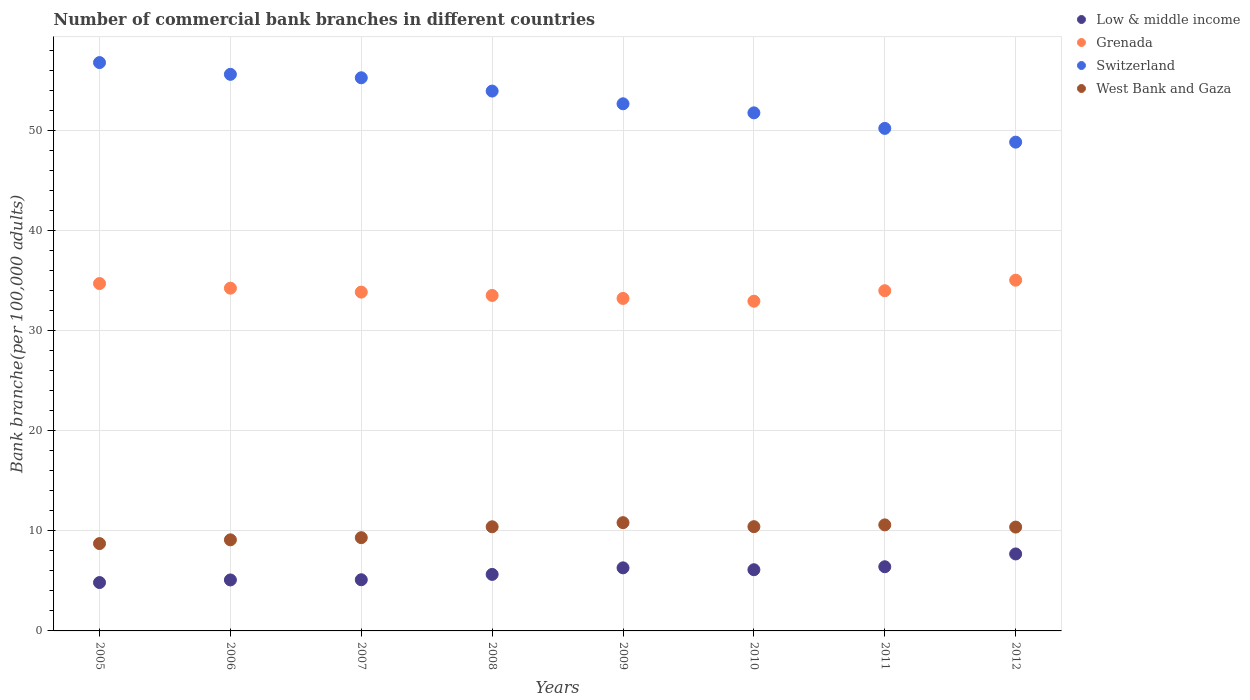Is the number of dotlines equal to the number of legend labels?
Your answer should be compact. Yes. What is the number of commercial bank branches in West Bank and Gaza in 2006?
Keep it short and to the point. 9.1. Across all years, what is the maximum number of commercial bank branches in West Bank and Gaza?
Ensure brevity in your answer.  10.82. Across all years, what is the minimum number of commercial bank branches in Low & middle income?
Ensure brevity in your answer.  4.83. In which year was the number of commercial bank branches in Low & middle income maximum?
Your answer should be very brief. 2012. In which year was the number of commercial bank branches in West Bank and Gaza minimum?
Make the answer very short. 2005. What is the total number of commercial bank branches in Grenada in the graph?
Ensure brevity in your answer.  271.55. What is the difference between the number of commercial bank branches in Grenada in 2007 and that in 2010?
Your response must be concise. 0.91. What is the difference between the number of commercial bank branches in Switzerland in 2008 and the number of commercial bank branches in Grenada in 2010?
Provide a short and direct response. 21. What is the average number of commercial bank branches in Switzerland per year?
Provide a succinct answer. 53.14. In the year 2006, what is the difference between the number of commercial bank branches in Low & middle income and number of commercial bank branches in Grenada?
Give a very brief answer. -29.15. What is the ratio of the number of commercial bank branches in Switzerland in 2007 to that in 2008?
Provide a short and direct response. 1.02. Is the number of commercial bank branches in Grenada in 2008 less than that in 2009?
Provide a succinct answer. No. What is the difference between the highest and the second highest number of commercial bank branches in West Bank and Gaza?
Your response must be concise. 0.22. What is the difference between the highest and the lowest number of commercial bank branches in Low & middle income?
Make the answer very short. 2.86. Is it the case that in every year, the sum of the number of commercial bank branches in West Bank and Gaza and number of commercial bank branches in Grenada  is greater than the sum of number of commercial bank branches in Switzerland and number of commercial bank branches in Low & middle income?
Provide a short and direct response. No. Is it the case that in every year, the sum of the number of commercial bank branches in Low & middle income and number of commercial bank branches in West Bank and Gaza  is greater than the number of commercial bank branches in Switzerland?
Provide a short and direct response. No. Is the number of commercial bank branches in Low & middle income strictly less than the number of commercial bank branches in West Bank and Gaza over the years?
Provide a succinct answer. Yes. What is the difference between two consecutive major ticks on the Y-axis?
Provide a succinct answer. 10. Where does the legend appear in the graph?
Provide a short and direct response. Top right. How many legend labels are there?
Your response must be concise. 4. How are the legend labels stacked?
Your answer should be compact. Vertical. What is the title of the graph?
Your answer should be compact. Number of commercial bank branches in different countries. Does "Middle income" appear as one of the legend labels in the graph?
Offer a very short reply. No. What is the label or title of the Y-axis?
Give a very brief answer. Bank branche(per 100,0 adults). What is the Bank branche(per 100,000 adults) in Low & middle income in 2005?
Provide a succinct answer. 4.83. What is the Bank branche(per 100,000 adults) in Grenada in 2005?
Provide a short and direct response. 34.71. What is the Bank branche(per 100,000 adults) of Switzerland in 2005?
Make the answer very short. 56.79. What is the Bank branche(per 100,000 adults) of West Bank and Gaza in 2005?
Offer a very short reply. 8.73. What is the Bank branche(per 100,000 adults) in Low & middle income in 2006?
Provide a succinct answer. 5.09. What is the Bank branche(per 100,000 adults) of Grenada in 2006?
Make the answer very short. 34.25. What is the Bank branche(per 100,000 adults) of Switzerland in 2006?
Your answer should be compact. 55.62. What is the Bank branche(per 100,000 adults) in West Bank and Gaza in 2006?
Make the answer very short. 9.1. What is the Bank branche(per 100,000 adults) in Low & middle income in 2007?
Offer a terse response. 5.11. What is the Bank branche(per 100,000 adults) of Grenada in 2007?
Your response must be concise. 33.86. What is the Bank branche(per 100,000 adults) of Switzerland in 2007?
Offer a terse response. 55.27. What is the Bank branche(per 100,000 adults) in West Bank and Gaza in 2007?
Your answer should be very brief. 9.32. What is the Bank branche(per 100,000 adults) of Low & middle income in 2008?
Your response must be concise. 5.65. What is the Bank branche(per 100,000 adults) of Grenada in 2008?
Provide a succinct answer. 33.52. What is the Bank branche(per 100,000 adults) of Switzerland in 2008?
Provide a succinct answer. 53.94. What is the Bank branche(per 100,000 adults) in West Bank and Gaza in 2008?
Provide a succinct answer. 10.41. What is the Bank branche(per 100,000 adults) of Low & middle income in 2009?
Keep it short and to the point. 6.3. What is the Bank branche(per 100,000 adults) of Grenada in 2009?
Give a very brief answer. 33.22. What is the Bank branche(per 100,000 adults) of Switzerland in 2009?
Provide a succinct answer. 52.67. What is the Bank branche(per 100,000 adults) of West Bank and Gaza in 2009?
Your answer should be compact. 10.82. What is the Bank branche(per 100,000 adults) of Low & middle income in 2010?
Give a very brief answer. 6.11. What is the Bank branche(per 100,000 adults) in Grenada in 2010?
Your answer should be compact. 32.95. What is the Bank branche(per 100,000 adults) of Switzerland in 2010?
Give a very brief answer. 51.77. What is the Bank branche(per 100,000 adults) in West Bank and Gaza in 2010?
Offer a terse response. 10.42. What is the Bank branche(per 100,000 adults) in Low & middle income in 2011?
Keep it short and to the point. 6.41. What is the Bank branche(per 100,000 adults) of Grenada in 2011?
Make the answer very short. 34. What is the Bank branche(per 100,000 adults) of Switzerland in 2011?
Give a very brief answer. 50.21. What is the Bank branche(per 100,000 adults) in West Bank and Gaza in 2011?
Make the answer very short. 10.6. What is the Bank branche(per 100,000 adults) in Low & middle income in 2012?
Give a very brief answer. 7.69. What is the Bank branche(per 100,000 adults) in Grenada in 2012?
Your response must be concise. 35.05. What is the Bank branche(per 100,000 adults) of Switzerland in 2012?
Give a very brief answer. 48.84. What is the Bank branche(per 100,000 adults) of West Bank and Gaza in 2012?
Your answer should be compact. 10.38. Across all years, what is the maximum Bank branche(per 100,000 adults) of Low & middle income?
Your answer should be very brief. 7.69. Across all years, what is the maximum Bank branche(per 100,000 adults) in Grenada?
Provide a succinct answer. 35.05. Across all years, what is the maximum Bank branche(per 100,000 adults) in Switzerland?
Your answer should be compact. 56.79. Across all years, what is the maximum Bank branche(per 100,000 adults) in West Bank and Gaza?
Keep it short and to the point. 10.82. Across all years, what is the minimum Bank branche(per 100,000 adults) of Low & middle income?
Your response must be concise. 4.83. Across all years, what is the minimum Bank branche(per 100,000 adults) of Grenada?
Provide a short and direct response. 32.95. Across all years, what is the minimum Bank branche(per 100,000 adults) of Switzerland?
Ensure brevity in your answer.  48.84. Across all years, what is the minimum Bank branche(per 100,000 adults) of West Bank and Gaza?
Make the answer very short. 8.73. What is the total Bank branche(per 100,000 adults) in Low & middle income in the graph?
Keep it short and to the point. 47.21. What is the total Bank branche(per 100,000 adults) in Grenada in the graph?
Offer a very short reply. 271.55. What is the total Bank branche(per 100,000 adults) in Switzerland in the graph?
Your answer should be compact. 425.12. What is the total Bank branche(per 100,000 adults) of West Bank and Gaza in the graph?
Your answer should be compact. 79.76. What is the difference between the Bank branche(per 100,000 adults) in Low & middle income in 2005 and that in 2006?
Offer a very short reply. -0.26. What is the difference between the Bank branche(per 100,000 adults) of Grenada in 2005 and that in 2006?
Ensure brevity in your answer.  0.46. What is the difference between the Bank branche(per 100,000 adults) of Switzerland in 2005 and that in 2006?
Make the answer very short. 1.18. What is the difference between the Bank branche(per 100,000 adults) in West Bank and Gaza in 2005 and that in 2006?
Make the answer very short. -0.37. What is the difference between the Bank branche(per 100,000 adults) of Low & middle income in 2005 and that in 2007?
Make the answer very short. -0.28. What is the difference between the Bank branche(per 100,000 adults) in Grenada in 2005 and that in 2007?
Provide a short and direct response. 0.85. What is the difference between the Bank branche(per 100,000 adults) in Switzerland in 2005 and that in 2007?
Keep it short and to the point. 1.52. What is the difference between the Bank branche(per 100,000 adults) of West Bank and Gaza in 2005 and that in 2007?
Ensure brevity in your answer.  -0.59. What is the difference between the Bank branche(per 100,000 adults) in Low & middle income in 2005 and that in 2008?
Offer a terse response. -0.81. What is the difference between the Bank branche(per 100,000 adults) in Grenada in 2005 and that in 2008?
Your answer should be compact. 1.19. What is the difference between the Bank branche(per 100,000 adults) in Switzerland in 2005 and that in 2008?
Ensure brevity in your answer.  2.85. What is the difference between the Bank branche(per 100,000 adults) of West Bank and Gaza in 2005 and that in 2008?
Your answer should be compact. -1.68. What is the difference between the Bank branche(per 100,000 adults) in Low & middle income in 2005 and that in 2009?
Your answer should be compact. -1.47. What is the difference between the Bank branche(per 100,000 adults) of Grenada in 2005 and that in 2009?
Keep it short and to the point. 1.49. What is the difference between the Bank branche(per 100,000 adults) of Switzerland in 2005 and that in 2009?
Your answer should be very brief. 4.12. What is the difference between the Bank branche(per 100,000 adults) of West Bank and Gaza in 2005 and that in 2009?
Provide a succinct answer. -2.09. What is the difference between the Bank branche(per 100,000 adults) in Low & middle income in 2005 and that in 2010?
Offer a very short reply. -1.28. What is the difference between the Bank branche(per 100,000 adults) of Grenada in 2005 and that in 2010?
Keep it short and to the point. 1.76. What is the difference between the Bank branche(per 100,000 adults) of Switzerland in 2005 and that in 2010?
Your answer should be compact. 5.02. What is the difference between the Bank branche(per 100,000 adults) of West Bank and Gaza in 2005 and that in 2010?
Your answer should be very brief. -1.69. What is the difference between the Bank branche(per 100,000 adults) of Low & middle income in 2005 and that in 2011?
Ensure brevity in your answer.  -1.58. What is the difference between the Bank branche(per 100,000 adults) of Grenada in 2005 and that in 2011?
Make the answer very short. 0.71. What is the difference between the Bank branche(per 100,000 adults) of Switzerland in 2005 and that in 2011?
Offer a terse response. 6.58. What is the difference between the Bank branche(per 100,000 adults) of West Bank and Gaza in 2005 and that in 2011?
Your response must be concise. -1.87. What is the difference between the Bank branche(per 100,000 adults) of Low & middle income in 2005 and that in 2012?
Ensure brevity in your answer.  -2.86. What is the difference between the Bank branche(per 100,000 adults) of Grenada in 2005 and that in 2012?
Offer a terse response. -0.34. What is the difference between the Bank branche(per 100,000 adults) in Switzerland in 2005 and that in 2012?
Your answer should be compact. 7.95. What is the difference between the Bank branche(per 100,000 adults) of West Bank and Gaza in 2005 and that in 2012?
Offer a very short reply. -1.65. What is the difference between the Bank branche(per 100,000 adults) of Low & middle income in 2006 and that in 2007?
Provide a short and direct response. -0.02. What is the difference between the Bank branche(per 100,000 adults) in Grenada in 2006 and that in 2007?
Your answer should be very brief. 0.39. What is the difference between the Bank branche(per 100,000 adults) in Switzerland in 2006 and that in 2007?
Give a very brief answer. 0.34. What is the difference between the Bank branche(per 100,000 adults) in West Bank and Gaza in 2006 and that in 2007?
Your answer should be very brief. -0.22. What is the difference between the Bank branche(per 100,000 adults) of Low & middle income in 2006 and that in 2008?
Provide a succinct answer. -0.55. What is the difference between the Bank branche(per 100,000 adults) in Grenada in 2006 and that in 2008?
Give a very brief answer. 0.73. What is the difference between the Bank branche(per 100,000 adults) in Switzerland in 2006 and that in 2008?
Offer a terse response. 1.67. What is the difference between the Bank branche(per 100,000 adults) of West Bank and Gaza in 2006 and that in 2008?
Your response must be concise. -1.3. What is the difference between the Bank branche(per 100,000 adults) in Low & middle income in 2006 and that in 2009?
Your response must be concise. -1.21. What is the difference between the Bank branche(per 100,000 adults) of Grenada in 2006 and that in 2009?
Keep it short and to the point. 1.02. What is the difference between the Bank branche(per 100,000 adults) of Switzerland in 2006 and that in 2009?
Provide a succinct answer. 2.94. What is the difference between the Bank branche(per 100,000 adults) in West Bank and Gaza in 2006 and that in 2009?
Offer a terse response. -1.72. What is the difference between the Bank branche(per 100,000 adults) of Low & middle income in 2006 and that in 2010?
Keep it short and to the point. -1.02. What is the difference between the Bank branche(per 100,000 adults) in Grenada in 2006 and that in 2010?
Make the answer very short. 1.3. What is the difference between the Bank branche(per 100,000 adults) of Switzerland in 2006 and that in 2010?
Offer a terse response. 3.85. What is the difference between the Bank branche(per 100,000 adults) in West Bank and Gaza in 2006 and that in 2010?
Offer a very short reply. -1.32. What is the difference between the Bank branche(per 100,000 adults) of Low & middle income in 2006 and that in 2011?
Offer a very short reply. -1.32. What is the difference between the Bank branche(per 100,000 adults) of Grenada in 2006 and that in 2011?
Provide a short and direct response. 0.25. What is the difference between the Bank branche(per 100,000 adults) of Switzerland in 2006 and that in 2011?
Your answer should be very brief. 5.4. What is the difference between the Bank branche(per 100,000 adults) of West Bank and Gaza in 2006 and that in 2011?
Give a very brief answer. -1.49. What is the difference between the Bank branche(per 100,000 adults) in Low & middle income in 2006 and that in 2012?
Offer a very short reply. -2.6. What is the difference between the Bank branche(per 100,000 adults) in Grenada in 2006 and that in 2012?
Offer a terse response. -0.8. What is the difference between the Bank branche(per 100,000 adults) of Switzerland in 2006 and that in 2012?
Your answer should be very brief. 6.78. What is the difference between the Bank branche(per 100,000 adults) in West Bank and Gaza in 2006 and that in 2012?
Offer a very short reply. -1.27. What is the difference between the Bank branche(per 100,000 adults) in Low & middle income in 2007 and that in 2008?
Ensure brevity in your answer.  -0.53. What is the difference between the Bank branche(per 100,000 adults) of Grenada in 2007 and that in 2008?
Keep it short and to the point. 0.33. What is the difference between the Bank branche(per 100,000 adults) in Switzerland in 2007 and that in 2008?
Your answer should be very brief. 1.33. What is the difference between the Bank branche(per 100,000 adults) in West Bank and Gaza in 2007 and that in 2008?
Ensure brevity in your answer.  -1.09. What is the difference between the Bank branche(per 100,000 adults) of Low & middle income in 2007 and that in 2009?
Your response must be concise. -1.19. What is the difference between the Bank branche(per 100,000 adults) of Grenada in 2007 and that in 2009?
Keep it short and to the point. 0.63. What is the difference between the Bank branche(per 100,000 adults) of Switzerland in 2007 and that in 2009?
Your response must be concise. 2.6. What is the difference between the Bank branche(per 100,000 adults) of West Bank and Gaza in 2007 and that in 2009?
Ensure brevity in your answer.  -1.5. What is the difference between the Bank branche(per 100,000 adults) in Low & middle income in 2007 and that in 2010?
Offer a very short reply. -1. What is the difference between the Bank branche(per 100,000 adults) in Grenada in 2007 and that in 2010?
Offer a very short reply. 0.91. What is the difference between the Bank branche(per 100,000 adults) of Switzerland in 2007 and that in 2010?
Your answer should be very brief. 3.5. What is the difference between the Bank branche(per 100,000 adults) of West Bank and Gaza in 2007 and that in 2010?
Offer a terse response. -1.1. What is the difference between the Bank branche(per 100,000 adults) of Low & middle income in 2007 and that in 2011?
Your response must be concise. -1.3. What is the difference between the Bank branche(per 100,000 adults) of Grenada in 2007 and that in 2011?
Your answer should be compact. -0.14. What is the difference between the Bank branche(per 100,000 adults) in Switzerland in 2007 and that in 2011?
Your answer should be compact. 5.06. What is the difference between the Bank branche(per 100,000 adults) in West Bank and Gaza in 2007 and that in 2011?
Offer a terse response. -1.28. What is the difference between the Bank branche(per 100,000 adults) of Low & middle income in 2007 and that in 2012?
Provide a succinct answer. -2.58. What is the difference between the Bank branche(per 100,000 adults) in Grenada in 2007 and that in 2012?
Your answer should be very brief. -1.19. What is the difference between the Bank branche(per 100,000 adults) in Switzerland in 2007 and that in 2012?
Your answer should be compact. 6.43. What is the difference between the Bank branche(per 100,000 adults) of West Bank and Gaza in 2007 and that in 2012?
Keep it short and to the point. -1.06. What is the difference between the Bank branche(per 100,000 adults) of Low & middle income in 2008 and that in 2009?
Offer a very short reply. -0.66. What is the difference between the Bank branche(per 100,000 adults) of Grenada in 2008 and that in 2009?
Offer a terse response. 0.3. What is the difference between the Bank branche(per 100,000 adults) of Switzerland in 2008 and that in 2009?
Provide a succinct answer. 1.27. What is the difference between the Bank branche(per 100,000 adults) of West Bank and Gaza in 2008 and that in 2009?
Provide a succinct answer. -0.41. What is the difference between the Bank branche(per 100,000 adults) in Low & middle income in 2008 and that in 2010?
Your answer should be very brief. -0.47. What is the difference between the Bank branche(per 100,000 adults) of Grenada in 2008 and that in 2010?
Provide a succinct answer. 0.58. What is the difference between the Bank branche(per 100,000 adults) in Switzerland in 2008 and that in 2010?
Provide a short and direct response. 2.18. What is the difference between the Bank branche(per 100,000 adults) in West Bank and Gaza in 2008 and that in 2010?
Your answer should be compact. -0.01. What is the difference between the Bank branche(per 100,000 adults) in Low & middle income in 2008 and that in 2011?
Your answer should be compact. -0.76. What is the difference between the Bank branche(per 100,000 adults) in Grenada in 2008 and that in 2011?
Provide a short and direct response. -0.47. What is the difference between the Bank branche(per 100,000 adults) in Switzerland in 2008 and that in 2011?
Ensure brevity in your answer.  3.73. What is the difference between the Bank branche(per 100,000 adults) of West Bank and Gaza in 2008 and that in 2011?
Make the answer very short. -0.19. What is the difference between the Bank branche(per 100,000 adults) in Low & middle income in 2008 and that in 2012?
Make the answer very short. -2.04. What is the difference between the Bank branche(per 100,000 adults) of Grenada in 2008 and that in 2012?
Offer a terse response. -1.52. What is the difference between the Bank branche(per 100,000 adults) in Switzerland in 2008 and that in 2012?
Give a very brief answer. 5.1. What is the difference between the Bank branche(per 100,000 adults) in West Bank and Gaza in 2008 and that in 2012?
Your answer should be very brief. 0.03. What is the difference between the Bank branche(per 100,000 adults) of Low & middle income in 2009 and that in 2010?
Make the answer very short. 0.19. What is the difference between the Bank branche(per 100,000 adults) of Grenada in 2009 and that in 2010?
Offer a very short reply. 0.28. What is the difference between the Bank branche(per 100,000 adults) of Switzerland in 2009 and that in 2010?
Your answer should be compact. 0.9. What is the difference between the Bank branche(per 100,000 adults) of West Bank and Gaza in 2009 and that in 2010?
Your answer should be very brief. 0.4. What is the difference between the Bank branche(per 100,000 adults) of Low & middle income in 2009 and that in 2011?
Ensure brevity in your answer.  -0.11. What is the difference between the Bank branche(per 100,000 adults) in Grenada in 2009 and that in 2011?
Your answer should be compact. -0.77. What is the difference between the Bank branche(per 100,000 adults) in Switzerland in 2009 and that in 2011?
Keep it short and to the point. 2.46. What is the difference between the Bank branche(per 100,000 adults) of West Bank and Gaza in 2009 and that in 2011?
Your answer should be very brief. 0.22. What is the difference between the Bank branche(per 100,000 adults) of Low & middle income in 2009 and that in 2012?
Give a very brief answer. -1.39. What is the difference between the Bank branche(per 100,000 adults) in Grenada in 2009 and that in 2012?
Your answer should be compact. -1.82. What is the difference between the Bank branche(per 100,000 adults) in Switzerland in 2009 and that in 2012?
Offer a terse response. 3.83. What is the difference between the Bank branche(per 100,000 adults) in West Bank and Gaza in 2009 and that in 2012?
Offer a very short reply. 0.44. What is the difference between the Bank branche(per 100,000 adults) of Low & middle income in 2010 and that in 2011?
Keep it short and to the point. -0.3. What is the difference between the Bank branche(per 100,000 adults) of Grenada in 2010 and that in 2011?
Ensure brevity in your answer.  -1.05. What is the difference between the Bank branche(per 100,000 adults) of Switzerland in 2010 and that in 2011?
Offer a very short reply. 1.55. What is the difference between the Bank branche(per 100,000 adults) of West Bank and Gaza in 2010 and that in 2011?
Offer a very short reply. -0.18. What is the difference between the Bank branche(per 100,000 adults) in Low & middle income in 2010 and that in 2012?
Provide a succinct answer. -1.58. What is the difference between the Bank branche(per 100,000 adults) of Grenada in 2010 and that in 2012?
Offer a very short reply. -2.1. What is the difference between the Bank branche(per 100,000 adults) of Switzerland in 2010 and that in 2012?
Offer a terse response. 2.93. What is the difference between the Bank branche(per 100,000 adults) in West Bank and Gaza in 2010 and that in 2012?
Offer a very short reply. 0.04. What is the difference between the Bank branche(per 100,000 adults) in Low & middle income in 2011 and that in 2012?
Provide a short and direct response. -1.28. What is the difference between the Bank branche(per 100,000 adults) in Grenada in 2011 and that in 2012?
Your response must be concise. -1.05. What is the difference between the Bank branche(per 100,000 adults) of Switzerland in 2011 and that in 2012?
Your answer should be compact. 1.37. What is the difference between the Bank branche(per 100,000 adults) of West Bank and Gaza in 2011 and that in 2012?
Provide a succinct answer. 0.22. What is the difference between the Bank branche(per 100,000 adults) of Low & middle income in 2005 and the Bank branche(per 100,000 adults) of Grenada in 2006?
Offer a very short reply. -29.41. What is the difference between the Bank branche(per 100,000 adults) of Low & middle income in 2005 and the Bank branche(per 100,000 adults) of Switzerland in 2006?
Your response must be concise. -50.78. What is the difference between the Bank branche(per 100,000 adults) in Low & middle income in 2005 and the Bank branche(per 100,000 adults) in West Bank and Gaza in 2006?
Offer a very short reply. -4.27. What is the difference between the Bank branche(per 100,000 adults) of Grenada in 2005 and the Bank branche(per 100,000 adults) of Switzerland in 2006?
Your answer should be very brief. -20.91. What is the difference between the Bank branche(per 100,000 adults) in Grenada in 2005 and the Bank branche(per 100,000 adults) in West Bank and Gaza in 2006?
Your answer should be very brief. 25.61. What is the difference between the Bank branche(per 100,000 adults) of Switzerland in 2005 and the Bank branche(per 100,000 adults) of West Bank and Gaza in 2006?
Provide a short and direct response. 47.69. What is the difference between the Bank branche(per 100,000 adults) of Low & middle income in 2005 and the Bank branche(per 100,000 adults) of Grenada in 2007?
Provide a succinct answer. -29.02. What is the difference between the Bank branche(per 100,000 adults) of Low & middle income in 2005 and the Bank branche(per 100,000 adults) of Switzerland in 2007?
Ensure brevity in your answer.  -50.44. What is the difference between the Bank branche(per 100,000 adults) of Low & middle income in 2005 and the Bank branche(per 100,000 adults) of West Bank and Gaza in 2007?
Provide a short and direct response. -4.49. What is the difference between the Bank branche(per 100,000 adults) in Grenada in 2005 and the Bank branche(per 100,000 adults) in Switzerland in 2007?
Keep it short and to the point. -20.56. What is the difference between the Bank branche(per 100,000 adults) in Grenada in 2005 and the Bank branche(per 100,000 adults) in West Bank and Gaza in 2007?
Offer a very short reply. 25.39. What is the difference between the Bank branche(per 100,000 adults) of Switzerland in 2005 and the Bank branche(per 100,000 adults) of West Bank and Gaza in 2007?
Provide a short and direct response. 47.47. What is the difference between the Bank branche(per 100,000 adults) in Low & middle income in 2005 and the Bank branche(per 100,000 adults) in Grenada in 2008?
Offer a very short reply. -28.69. What is the difference between the Bank branche(per 100,000 adults) in Low & middle income in 2005 and the Bank branche(per 100,000 adults) in Switzerland in 2008?
Offer a terse response. -49.11. What is the difference between the Bank branche(per 100,000 adults) of Low & middle income in 2005 and the Bank branche(per 100,000 adults) of West Bank and Gaza in 2008?
Your response must be concise. -5.57. What is the difference between the Bank branche(per 100,000 adults) of Grenada in 2005 and the Bank branche(per 100,000 adults) of Switzerland in 2008?
Your answer should be very brief. -19.23. What is the difference between the Bank branche(per 100,000 adults) in Grenada in 2005 and the Bank branche(per 100,000 adults) in West Bank and Gaza in 2008?
Ensure brevity in your answer.  24.3. What is the difference between the Bank branche(per 100,000 adults) in Switzerland in 2005 and the Bank branche(per 100,000 adults) in West Bank and Gaza in 2008?
Keep it short and to the point. 46.39. What is the difference between the Bank branche(per 100,000 adults) in Low & middle income in 2005 and the Bank branche(per 100,000 adults) in Grenada in 2009?
Your response must be concise. -28.39. What is the difference between the Bank branche(per 100,000 adults) in Low & middle income in 2005 and the Bank branche(per 100,000 adults) in Switzerland in 2009?
Keep it short and to the point. -47.84. What is the difference between the Bank branche(per 100,000 adults) of Low & middle income in 2005 and the Bank branche(per 100,000 adults) of West Bank and Gaza in 2009?
Provide a short and direct response. -5.98. What is the difference between the Bank branche(per 100,000 adults) of Grenada in 2005 and the Bank branche(per 100,000 adults) of Switzerland in 2009?
Your answer should be very brief. -17.96. What is the difference between the Bank branche(per 100,000 adults) in Grenada in 2005 and the Bank branche(per 100,000 adults) in West Bank and Gaza in 2009?
Your answer should be very brief. 23.89. What is the difference between the Bank branche(per 100,000 adults) of Switzerland in 2005 and the Bank branche(per 100,000 adults) of West Bank and Gaza in 2009?
Offer a terse response. 45.97. What is the difference between the Bank branche(per 100,000 adults) in Low & middle income in 2005 and the Bank branche(per 100,000 adults) in Grenada in 2010?
Give a very brief answer. -28.11. What is the difference between the Bank branche(per 100,000 adults) of Low & middle income in 2005 and the Bank branche(per 100,000 adults) of Switzerland in 2010?
Give a very brief answer. -46.93. What is the difference between the Bank branche(per 100,000 adults) in Low & middle income in 2005 and the Bank branche(per 100,000 adults) in West Bank and Gaza in 2010?
Make the answer very short. -5.58. What is the difference between the Bank branche(per 100,000 adults) in Grenada in 2005 and the Bank branche(per 100,000 adults) in Switzerland in 2010?
Make the answer very short. -17.06. What is the difference between the Bank branche(per 100,000 adults) of Grenada in 2005 and the Bank branche(per 100,000 adults) of West Bank and Gaza in 2010?
Your response must be concise. 24.29. What is the difference between the Bank branche(per 100,000 adults) in Switzerland in 2005 and the Bank branche(per 100,000 adults) in West Bank and Gaza in 2010?
Make the answer very short. 46.37. What is the difference between the Bank branche(per 100,000 adults) in Low & middle income in 2005 and the Bank branche(per 100,000 adults) in Grenada in 2011?
Offer a terse response. -29.16. What is the difference between the Bank branche(per 100,000 adults) in Low & middle income in 2005 and the Bank branche(per 100,000 adults) in Switzerland in 2011?
Keep it short and to the point. -45.38. What is the difference between the Bank branche(per 100,000 adults) of Low & middle income in 2005 and the Bank branche(per 100,000 adults) of West Bank and Gaza in 2011?
Ensure brevity in your answer.  -5.76. What is the difference between the Bank branche(per 100,000 adults) of Grenada in 2005 and the Bank branche(per 100,000 adults) of Switzerland in 2011?
Make the answer very short. -15.5. What is the difference between the Bank branche(per 100,000 adults) of Grenada in 2005 and the Bank branche(per 100,000 adults) of West Bank and Gaza in 2011?
Make the answer very short. 24.11. What is the difference between the Bank branche(per 100,000 adults) in Switzerland in 2005 and the Bank branche(per 100,000 adults) in West Bank and Gaza in 2011?
Offer a very short reply. 46.2. What is the difference between the Bank branche(per 100,000 adults) in Low & middle income in 2005 and the Bank branche(per 100,000 adults) in Grenada in 2012?
Give a very brief answer. -30.21. What is the difference between the Bank branche(per 100,000 adults) in Low & middle income in 2005 and the Bank branche(per 100,000 adults) in Switzerland in 2012?
Offer a terse response. -44.01. What is the difference between the Bank branche(per 100,000 adults) of Low & middle income in 2005 and the Bank branche(per 100,000 adults) of West Bank and Gaza in 2012?
Offer a terse response. -5.54. What is the difference between the Bank branche(per 100,000 adults) in Grenada in 2005 and the Bank branche(per 100,000 adults) in Switzerland in 2012?
Keep it short and to the point. -14.13. What is the difference between the Bank branche(per 100,000 adults) in Grenada in 2005 and the Bank branche(per 100,000 adults) in West Bank and Gaza in 2012?
Offer a terse response. 24.33. What is the difference between the Bank branche(per 100,000 adults) of Switzerland in 2005 and the Bank branche(per 100,000 adults) of West Bank and Gaza in 2012?
Provide a succinct answer. 46.42. What is the difference between the Bank branche(per 100,000 adults) in Low & middle income in 2006 and the Bank branche(per 100,000 adults) in Grenada in 2007?
Your answer should be very brief. -28.76. What is the difference between the Bank branche(per 100,000 adults) of Low & middle income in 2006 and the Bank branche(per 100,000 adults) of Switzerland in 2007?
Ensure brevity in your answer.  -50.18. What is the difference between the Bank branche(per 100,000 adults) in Low & middle income in 2006 and the Bank branche(per 100,000 adults) in West Bank and Gaza in 2007?
Your answer should be compact. -4.22. What is the difference between the Bank branche(per 100,000 adults) in Grenada in 2006 and the Bank branche(per 100,000 adults) in Switzerland in 2007?
Offer a very short reply. -21.02. What is the difference between the Bank branche(per 100,000 adults) of Grenada in 2006 and the Bank branche(per 100,000 adults) of West Bank and Gaza in 2007?
Offer a terse response. 24.93. What is the difference between the Bank branche(per 100,000 adults) of Switzerland in 2006 and the Bank branche(per 100,000 adults) of West Bank and Gaza in 2007?
Your answer should be compact. 46.3. What is the difference between the Bank branche(per 100,000 adults) in Low & middle income in 2006 and the Bank branche(per 100,000 adults) in Grenada in 2008?
Provide a succinct answer. -28.43. What is the difference between the Bank branche(per 100,000 adults) in Low & middle income in 2006 and the Bank branche(per 100,000 adults) in Switzerland in 2008?
Offer a very short reply. -48.85. What is the difference between the Bank branche(per 100,000 adults) of Low & middle income in 2006 and the Bank branche(per 100,000 adults) of West Bank and Gaza in 2008?
Offer a very short reply. -5.31. What is the difference between the Bank branche(per 100,000 adults) in Grenada in 2006 and the Bank branche(per 100,000 adults) in Switzerland in 2008?
Your answer should be very brief. -19.7. What is the difference between the Bank branche(per 100,000 adults) in Grenada in 2006 and the Bank branche(per 100,000 adults) in West Bank and Gaza in 2008?
Your response must be concise. 23.84. What is the difference between the Bank branche(per 100,000 adults) in Switzerland in 2006 and the Bank branche(per 100,000 adults) in West Bank and Gaza in 2008?
Your answer should be compact. 45.21. What is the difference between the Bank branche(per 100,000 adults) in Low & middle income in 2006 and the Bank branche(per 100,000 adults) in Grenada in 2009?
Provide a succinct answer. -28.13. What is the difference between the Bank branche(per 100,000 adults) of Low & middle income in 2006 and the Bank branche(per 100,000 adults) of Switzerland in 2009?
Offer a very short reply. -47.58. What is the difference between the Bank branche(per 100,000 adults) in Low & middle income in 2006 and the Bank branche(per 100,000 adults) in West Bank and Gaza in 2009?
Offer a terse response. -5.72. What is the difference between the Bank branche(per 100,000 adults) in Grenada in 2006 and the Bank branche(per 100,000 adults) in Switzerland in 2009?
Offer a terse response. -18.42. What is the difference between the Bank branche(per 100,000 adults) in Grenada in 2006 and the Bank branche(per 100,000 adults) in West Bank and Gaza in 2009?
Your answer should be compact. 23.43. What is the difference between the Bank branche(per 100,000 adults) in Switzerland in 2006 and the Bank branche(per 100,000 adults) in West Bank and Gaza in 2009?
Ensure brevity in your answer.  44.8. What is the difference between the Bank branche(per 100,000 adults) of Low & middle income in 2006 and the Bank branche(per 100,000 adults) of Grenada in 2010?
Offer a very short reply. -27.85. What is the difference between the Bank branche(per 100,000 adults) in Low & middle income in 2006 and the Bank branche(per 100,000 adults) in Switzerland in 2010?
Offer a very short reply. -46.67. What is the difference between the Bank branche(per 100,000 adults) of Low & middle income in 2006 and the Bank branche(per 100,000 adults) of West Bank and Gaza in 2010?
Your answer should be very brief. -5.32. What is the difference between the Bank branche(per 100,000 adults) in Grenada in 2006 and the Bank branche(per 100,000 adults) in Switzerland in 2010?
Provide a succinct answer. -17.52. What is the difference between the Bank branche(per 100,000 adults) of Grenada in 2006 and the Bank branche(per 100,000 adults) of West Bank and Gaza in 2010?
Offer a terse response. 23.83. What is the difference between the Bank branche(per 100,000 adults) of Switzerland in 2006 and the Bank branche(per 100,000 adults) of West Bank and Gaza in 2010?
Provide a short and direct response. 45.2. What is the difference between the Bank branche(per 100,000 adults) in Low & middle income in 2006 and the Bank branche(per 100,000 adults) in Grenada in 2011?
Your answer should be very brief. -28.9. What is the difference between the Bank branche(per 100,000 adults) in Low & middle income in 2006 and the Bank branche(per 100,000 adults) in Switzerland in 2011?
Offer a very short reply. -45.12. What is the difference between the Bank branche(per 100,000 adults) in Low & middle income in 2006 and the Bank branche(per 100,000 adults) in West Bank and Gaza in 2011?
Your answer should be very brief. -5.5. What is the difference between the Bank branche(per 100,000 adults) in Grenada in 2006 and the Bank branche(per 100,000 adults) in Switzerland in 2011?
Offer a very short reply. -15.97. What is the difference between the Bank branche(per 100,000 adults) in Grenada in 2006 and the Bank branche(per 100,000 adults) in West Bank and Gaza in 2011?
Your answer should be compact. 23.65. What is the difference between the Bank branche(per 100,000 adults) of Switzerland in 2006 and the Bank branche(per 100,000 adults) of West Bank and Gaza in 2011?
Ensure brevity in your answer.  45.02. What is the difference between the Bank branche(per 100,000 adults) of Low & middle income in 2006 and the Bank branche(per 100,000 adults) of Grenada in 2012?
Offer a terse response. -29.95. What is the difference between the Bank branche(per 100,000 adults) of Low & middle income in 2006 and the Bank branche(per 100,000 adults) of Switzerland in 2012?
Ensure brevity in your answer.  -43.75. What is the difference between the Bank branche(per 100,000 adults) of Low & middle income in 2006 and the Bank branche(per 100,000 adults) of West Bank and Gaza in 2012?
Provide a short and direct response. -5.28. What is the difference between the Bank branche(per 100,000 adults) of Grenada in 2006 and the Bank branche(per 100,000 adults) of Switzerland in 2012?
Ensure brevity in your answer.  -14.59. What is the difference between the Bank branche(per 100,000 adults) in Grenada in 2006 and the Bank branche(per 100,000 adults) in West Bank and Gaza in 2012?
Keep it short and to the point. 23.87. What is the difference between the Bank branche(per 100,000 adults) of Switzerland in 2006 and the Bank branche(per 100,000 adults) of West Bank and Gaza in 2012?
Ensure brevity in your answer.  45.24. What is the difference between the Bank branche(per 100,000 adults) in Low & middle income in 2007 and the Bank branche(per 100,000 adults) in Grenada in 2008?
Offer a terse response. -28.41. What is the difference between the Bank branche(per 100,000 adults) of Low & middle income in 2007 and the Bank branche(per 100,000 adults) of Switzerland in 2008?
Your response must be concise. -48.83. What is the difference between the Bank branche(per 100,000 adults) in Low & middle income in 2007 and the Bank branche(per 100,000 adults) in West Bank and Gaza in 2008?
Ensure brevity in your answer.  -5.29. What is the difference between the Bank branche(per 100,000 adults) in Grenada in 2007 and the Bank branche(per 100,000 adults) in Switzerland in 2008?
Provide a short and direct response. -20.09. What is the difference between the Bank branche(per 100,000 adults) of Grenada in 2007 and the Bank branche(per 100,000 adults) of West Bank and Gaza in 2008?
Ensure brevity in your answer.  23.45. What is the difference between the Bank branche(per 100,000 adults) of Switzerland in 2007 and the Bank branche(per 100,000 adults) of West Bank and Gaza in 2008?
Provide a succinct answer. 44.87. What is the difference between the Bank branche(per 100,000 adults) of Low & middle income in 2007 and the Bank branche(per 100,000 adults) of Grenada in 2009?
Give a very brief answer. -28.11. What is the difference between the Bank branche(per 100,000 adults) of Low & middle income in 2007 and the Bank branche(per 100,000 adults) of Switzerland in 2009?
Give a very brief answer. -47.56. What is the difference between the Bank branche(per 100,000 adults) in Low & middle income in 2007 and the Bank branche(per 100,000 adults) in West Bank and Gaza in 2009?
Provide a succinct answer. -5.71. What is the difference between the Bank branche(per 100,000 adults) in Grenada in 2007 and the Bank branche(per 100,000 adults) in Switzerland in 2009?
Provide a short and direct response. -18.82. What is the difference between the Bank branche(per 100,000 adults) in Grenada in 2007 and the Bank branche(per 100,000 adults) in West Bank and Gaza in 2009?
Make the answer very short. 23.04. What is the difference between the Bank branche(per 100,000 adults) in Switzerland in 2007 and the Bank branche(per 100,000 adults) in West Bank and Gaza in 2009?
Give a very brief answer. 44.45. What is the difference between the Bank branche(per 100,000 adults) in Low & middle income in 2007 and the Bank branche(per 100,000 adults) in Grenada in 2010?
Offer a terse response. -27.83. What is the difference between the Bank branche(per 100,000 adults) of Low & middle income in 2007 and the Bank branche(per 100,000 adults) of Switzerland in 2010?
Make the answer very short. -46.66. What is the difference between the Bank branche(per 100,000 adults) in Low & middle income in 2007 and the Bank branche(per 100,000 adults) in West Bank and Gaza in 2010?
Your answer should be very brief. -5.31. What is the difference between the Bank branche(per 100,000 adults) of Grenada in 2007 and the Bank branche(per 100,000 adults) of Switzerland in 2010?
Keep it short and to the point. -17.91. What is the difference between the Bank branche(per 100,000 adults) in Grenada in 2007 and the Bank branche(per 100,000 adults) in West Bank and Gaza in 2010?
Ensure brevity in your answer.  23.44. What is the difference between the Bank branche(per 100,000 adults) of Switzerland in 2007 and the Bank branche(per 100,000 adults) of West Bank and Gaza in 2010?
Your response must be concise. 44.86. What is the difference between the Bank branche(per 100,000 adults) in Low & middle income in 2007 and the Bank branche(per 100,000 adults) in Grenada in 2011?
Ensure brevity in your answer.  -28.88. What is the difference between the Bank branche(per 100,000 adults) of Low & middle income in 2007 and the Bank branche(per 100,000 adults) of Switzerland in 2011?
Ensure brevity in your answer.  -45.1. What is the difference between the Bank branche(per 100,000 adults) of Low & middle income in 2007 and the Bank branche(per 100,000 adults) of West Bank and Gaza in 2011?
Provide a short and direct response. -5.48. What is the difference between the Bank branche(per 100,000 adults) in Grenada in 2007 and the Bank branche(per 100,000 adults) in Switzerland in 2011?
Offer a terse response. -16.36. What is the difference between the Bank branche(per 100,000 adults) in Grenada in 2007 and the Bank branche(per 100,000 adults) in West Bank and Gaza in 2011?
Provide a short and direct response. 23.26. What is the difference between the Bank branche(per 100,000 adults) of Switzerland in 2007 and the Bank branche(per 100,000 adults) of West Bank and Gaza in 2011?
Offer a terse response. 44.68. What is the difference between the Bank branche(per 100,000 adults) in Low & middle income in 2007 and the Bank branche(per 100,000 adults) in Grenada in 2012?
Give a very brief answer. -29.93. What is the difference between the Bank branche(per 100,000 adults) in Low & middle income in 2007 and the Bank branche(per 100,000 adults) in Switzerland in 2012?
Offer a very short reply. -43.73. What is the difference between the Bank branche(per 100,000 adults) of Low & middle income in 2007 and the Bank branche(per 100,000 adults) of West Bank and Gaza in 2012?
Your response must be concise. -5.26. What is the difference between the Bank branche(per 100,000 adults) in Grenada in 2007 and the Bank branche(per 100,000 adults) in Switzerland in 2012?
Make the answer very short. -14.99. What is the difference between the Bank branche(per 100,000 adults) of Grenada in 2007 and the Bank branche(per 100,000 adults) of West Bank and Gaza in 2012?
Keep it short and to the point. 23.48. What is the difference between the Bank branche(per 100,000 adults) in Switzerland in 2007 and the Bank branche(per 100,000 adults) in West Bank and Gaza in 2012?
Ensure brevity in your answer.  44.9. What is the difference between the Bank branche(per 100,000 adults) in Low & middle income in 2008 and the Bank branche(per 100,000 adults) in Grenada in 2009?
Keep it short and to the point. -27.58. What is the difference between the Bank branche(per 100,000 adults) of Low & middle income in 2008 and the Bank branche(per 100,000 adults) of Switzerland in 2009?
Give a very brief answer. -47.03. What is the difference between the Bank branche(per 100,000 adults) in Low & middle income in 2008 and the Bank branche(per 100,000 adults) in West Bank and Gaza in 2009?
Keep it short and to the point. -5.17. What is the difference between the Bank branche(per 100,000 adults) of Grenada in 2008 and the Bank branche(per 100,000 adults) of Switzerland in 2009?
Offer a very short reply. -19.15. What is the difference between the Bank branche(per 100,000 adults) in Grenada in 2008 and the Bank branche(per 100,000 adults) in West Bank and Gaza in 2009?
Your answer should be very brief. 22.7. What is the difference between the Bank branche(per 100,000 adults) in Switzerland in 2008 and the Bank branche(per 100,000 adults) in West Bank and Gaza in 2009?
Make the answer very short. 43.13. What is the difference between the Bank branche(per 100,000 adults) in Low & middle income in 2008 and the Bank branche(per 100,000 adults) in Grenada in 2010?
Make the answer very short. -27.3. What is the difference between the Bank branche(per 100,000 adults) of Low & middle income in 2008 and the Bank branche(per 100,000 adults) of Switzerland in 2010?
Offer a terse response. -46.12. What is the difference between the Bank branche(per 100,000 adults) in Low & middle income in 2008 and the Bank branche(per 100,000 adults) in West Bank and Gaza in 2010?
Your response must be concise. -4.77. What is the difference between the Bank branche(per 100,000 adults) in Grenada in 2008 and the Bank branche(per 100,000 adults) in Switzerland in 2010?
Provide a succinct answer. -18.25. What is the difference between the Bank branche(per 100,000 adults) in Grenada in 2008 and the Bank branche(per 100,000 adults) in West Bank and Gaza in 2010?
Your response must be concise. 23.1. What is the difference between the Bank branche(per 100,000 adults) in Switzerland in 2008 and the Bank branche(per 100,000 adults) in West Bank and Gaza in 2010?
Ensure brevity in your answer.  43.53. What is the difference between the Bank branche(per 100,000 adults) of Low & middle income in 2008 and the Bank branche(per 100,000 adults) of Grenada in 2011?
Provide a succinct answer. -28.35. What is the difference between the Bank branche(per 100,000 adults) in Low & middle income in 2008 and the Bank branche(per 100,000 adults) in Switzerland in 2011?
Offer a terse response. -44.57. What is the difference between the Bank branche(per 100,000 adults) of Low & middle income in 2008 and the Bank branche(per 100,000 adults) of West Bank and Gaza in 2011?
Offer a terse response. -4.95. What is the difference between the Bank branche(per 100,000 adults) in Grenada in 2008 and the Bank branche(per 100,000 adults) in Switzerland in 2011?
Ensure brevity in your answer.  -16.69. What is the difference between the Bank branche(per 100,000 adults) of Grenada in 2008 and the Bank branche(per 100,000 adults) of West Bank and Gaza in 2011?
Give a very brief answer. 22.93. What is the difference between the Bank branche(per 100,000 adults) in Switzerland in 2008 and the Bank branche(per 100,000 adults) in West Bank and Gaza in 2011?
Give a very brief answer. 43.35. What is the difference between the Bank branche(per 100,000 adults) in Low & middle income in 2008 and the Bank branche(per 100,000 adults) in Grenada in 2012?
Provide a succinct answer. -29.4. What is the difference between the Bank branche(per 100,000 adults) of Low & middle income in 2008 and the Bank branche(per 100,000 adults) of Switzerland in 2012?
Ensure brevity in your answer.  -43.19. What is the difference between the Bank branche(per 100,000 adults) in Low & middle income in 2008 and the Bank branche(per 100,000 adults) in West Bank and Gaza in 2012?
Give a very brief answer. -4.73. What is the difference between the Bank branche(per 100,000 adults) of Grenada in 2008 and the Bank branche(per 100,000 adults) of Switzerland in 2012?
Your response must be concise. -15.32. What is the difference between the Bank branche(per 100,000 adults) of Grenada in 2008 and the Bank branche(per 100,000 adults) of West Bank and Gaza in 2012?
Give a very brief answer. 23.15. What is the difference between the Bank branche(per 100,000 adults) in Switzerland in 2008 and the Bank branche(per 100,000 adults) in West Bank and Gaza in 2012?
Keep it short and to the point. 43.57. What is the difference between the Bank branche(per 100,000 adults) of Low & middle income in 2009 and the Bank branche(per 100,000 adults) of Grenada in 2010?
Your answer should be very brief. -26.64. What is the difference between the Bank branche(per 100,000 adults) of Low & middle income in 2009 and the Bank branche(per 100,000 adults) of Switzerland in 2010?
Your response must be concise. -45.47. What is the difference between the Bank branche(per 100,000 adults) in Low & middle income in 2009 and the Bank branche(per 100,000 adults) in West Bank and Gaza in 2010?
Provide a short and direct response. -4.12. What is the difference between the Bank branche(per 100,000 adults) in Grenada in 2009 and the Bank branche(per 100,000 adults) in Switzerland in 2010?
Make the answer very short. -18.54. What is the difference between the Bank branche(per 100,000 adults) in Grenada in 2009 and the Bank branche(per 100,000 adults) in West Bank and Gaza in 2010?
Keep it short and to the point. 22.81. What is the difference between the Bank branche(per 100,000 adults) of Switzerland in 2009 and the Bank branche(per 100,000 adults) of West Bank and Gaza in 2010?
Ensure brevity in your answer.  42.26. What is the difference between the Bank branche(per 100,000 adults) of Low & middle income in 2009 and the Bank branche(per 100,000 adults) of Grenada in 2011?
Make the answer very short. -27.69. What is the difference between the Bank branche(per 100,000 adults) in Low & middle income in 2009 and the Bank branche(per 100,000 adults) in Switzerland in 2011?
Provide a succinct answer. -43.91. What is the difference between the Bank branche(per 100,000 adults) of Low & middle income in 2009 and the Bank branche(per 100,000 adults) of West Bank and Gaza in 2011?
Give a very brief answer. -4.29. What is the difference between the Bank branche(per 100,000 adults) in Grenada in 2009 and the Bank branche(per 100,000 adults) in Switzerland in 2011?
Offer a very short reply. -16.99. What is the difference between the Bank branche(per 100,000 adults) of Grenada in 2009 and the Bank branche(per 100,000 adults) of West Bank and Gaza in 2011?
Provide a short and direct response. 22.63. What is the difference between the Bank branche(per 100,000 adults) in Switzerland in 2009 and the Bank branche(per 100,000 adults) in West Bank and Gaza in 2011?
Your response must be concise. 42.08. What is the difference between the Bank branche(per 100,000 adults) in Low & middle income in 2009 and the Bank branche(per 100,000 adults) in Grenada in 2012?
Give a very brief answer. -28.74. What is the difference between the Bank branche(per 100,000 adults) in Low & middle income in 2009 and the Bank branche(per 100,000 adults) in Switzerland in 2012?
Provide a succinct answer. -42.54. What is the difference between the Bank branche(per 100,000 adults) of Low & middle income in 2009 and the Bank branche(per 100,000 adults) of West Bank and Gaza in 2012?
Provide a succinct answer. -4.07. What is the difference between the Bank branche(per 100,000 adults) of Grenada in 2009 and the Bank branche(per 100,000 adults) of Switzerland in 2012?
Keep it short and to the point. -15.62. What is the difference between the Bank branche(per 100,000 adults) of Grenada in 2009 and the Bank branche(per 100,000 adults) of West Bank and Gaza in 2012?
Provide a succinct answer. 22.85. What is the difference between the Bank branche(per 100,000 adults) of Switzerland in 2009 and the Bank branche(per 100,000 adults) of West Bank and Gaza in 2012?
Your answer should be very brief. 42.3. What is the difference between the Bank branche(per 100,000 adults) of Low & middle income in 2010 and the Bank branche(per 100,000 adults) of Grenada in 2011?
Offer a terse response. -27.88. What is the difference between the Bank branche(per 100,000 adults) in Low & middle income in 2010 and the Bank branche(per 100,000 adults) in Switzerland in 2011?
Offer a very short reply. -44.1. What is the difference between the Bank branche(per 100,000 adults) of Low & middle income in 2010 and the Bank branche(per 100,000 adults) of West Bank and Gaza in 2011?
Offer a very short reply. -4.48. What is the difference between the Bank branche(per 100,000 adults) of Grenada in 2010 and the Bank branche(per 100,000 adults) of Switzerland in 2011?
Keep it short and to the point. -17.27. What is the difference between the Bank branche(per 100,000 adults) of Grenada in 2010 and the Bank branche(per 100,000 adults) of West Bank and Gaza in 2011?
Provide a succinct answer. 22.35. What is the difference between the Bank branche(per 100,000 adults) in Switzerland in 2010 and the Bank branche(per 100,000 adults) in West Bank and Gaza in 2011?
Give a very brief answer. 41.17. What is the difference between the Bank branche(per 100,000 adults) of Low & middle income in 2010 and the Bank branche(per 100,000 adults) of Grenada in 2012?
Ensure brevity in your answer.  -28.93. What is the difference between the Bank branche(per 100,000 adults) of Low & middle income in 2010 and the Bank branche(per 100,000 adults) of Switzerland in 2012?
Offer a very short reply. -42.73. What is the difference between the Bank branche(per 100,000 adults) of Low & middle income in 2010 and the Bank branche(per 100,000 adults) of West Bank and Gaza in 2012?
Your answer should be very brief. -4.26. What is the difference between the Bank branche(per 100,000 adults) in Grenada in 2010 and the Bank branche(per 100,000 adults) in Switzerland in 2012?
Give a very brief answer. -15.89. What is the difference between the Bank branche(per 100,000 adults) of Grenada in 2010 and the Bank branche(per 100,000 adults) of West Bank and Gaza in 2012?
Keep it short and to the point. 22.57. What is the difference between the Bank branche(per 100,000 adults) in Switzerland in 2010 and the Bank branche(per 100,000 adults) in West Bank and Gaza in 2012?
Your answer should be very brief. 41.39. What is the difference between the Bank branche(per 100,000 adults) of Low & middle income in 2011 and the Bank branche(per 100,000 adults) of Grenada in 2012?
Ensure brevity in your answer.  -28.63. What is the difference between the Bank branche(per 100,000 adults) of Low & middle income in 2011 and the Bank branche(per 100,000 adults) of Switzerland in 2012?
Your answer should be very brief. -42.43. What is the difference between the Bank branche(per 100,000 adults) of Low & middle income in 2011 and the Bank branche(per 100,000 adults) of West Bank and Gaza in 2012?
Provide a short and direct response. -3.96. What is the difference between the Bank branche(per 100,000 adults) in Grenada in 2011 and the Bank branche(per 100,000 adults) in Switzerland in 2012?
Give a very brief answer. -14.85. What is the difference between the Bank branche(per 100,000 adults) in Grenada in 2011 and the Bank branche(per 100,000 adults) in West Bank and Gaza in 2012?
Your answer should be compact. 23.62. What is the difference between the Bank branche(per 100,000 adults) in Switzerland in 2011 and the Bank branche(per 100,000 adults) in West Bank and Gaza in 2012?
Provide a short and direct response. 39.84. What is the average Bank branche(per 100,000 adults) in Low & middle income per year?
Provide a short and direct response. 5.9. What is the average Bank branche(per 100,000 adults) in Grenada per year?
Keep it short and to the point. 33.94. What is the average Bank branche(per 100,000 adults) in Switzerland per year?
Keep it short and to the point. 53.14. What is the average Bank branche(per 100,000 adults) of West Bank and Gaza per year?
Your answer should be compact. 9.97. In the year 2005, what is the difference between the Bank branche(per 100,000 adults) in Low & middle income and Bank branche(per 100,000 adults) in Grenada?
Offer a terse response. -29.88. In the year 2005, what is the difference between the Bank branche(per 100,000 adults) of Low & middle income and Bank branche(per 100,000 adults) of Switzerland?
Provide a succinct answer. -51.96. In the year 2005, what is the difference between the Bank branche(per 100,000 adults) in Low & middle income and Bank branche(per 100,000 adults) in West Bank and Gaza?
Your answer should be very brief. -3.89. In the year 2005, what is the difference between the Bank branche(per 100,000 adults) in Grenada and Bank branche(per 100,000 adults) in Switzerland?
Give a very brief answer. -22.08. In the year 2005, what is the difference between the Bank branche(per 100,000 adults) in Grenada and Bank branche(per 100,000 adults) in West Bank and Gaza?
Make the answer very short. 25.98. In the year 2005, what is the difference between the Bank branche(per 100,000 adults) in Switzerland and Bank branche(per 100,000 adults) in West Bank and Gaza?
Your answer should be very brief. 48.06. In the year 2006, what is the difference between the Bank branche(per 100,000 adults) in Low & middle income and Bank branche(per 100,000 adults) in Grenada?
Your answer should be compact. -29.15. In the year 2006, what is the difference between the Bank branche(per 100,000 adults) in Low & middle income and Bank branche(per 100,000 adults) in Switzerland?
Make the answer very short. -50.52. In the year 2006, what is the difference between the Bank branche(per 100,000 adults) in Low & middle income and Bank branche(per 100,000 adults) in West Bank and Gaza?
Provide a short and direct response. -4.01. In the year 2006, what is the difference between the Bank branche(per 100,000 adults) of Grenada and Bank branche(per 100,000 adults) of Switzerland?
Your answer should be very brief. -21.37. In the year 2006, what is the difference between the Bank branche(per 100,000 adults) of Grenada and Bank branche(per 100,000 adults) of West Bank and Gaza?
Your response must be concise. 25.15. In the year 2006, what is the difference between the Bank branche(per 100,000 adults) of Switzerland and Bank branche(per 100,000 adults) of West Bank and Gaza?
Your response must be concise. 46.51. In the year 2007, what is the difference between the Bank branche(per 100,000 adults) of Low & middle income and Bank branche(per 100,000 adults) of Grenada?
Your answer should be very brief. -28.74. In the year 2007, what is the difference between the Bank branche(per 100,000 adults) of Low & middle income and Bank branche(per 100,000 adults) of Switzerland?
Give a very brief answer. -50.16. In the year 2007, what is the difference between the Bank branche(per 100,000 adults) in Low & middle income and Bank branche(per 100,000 adults) in West Bank and Gaza?
Give a very brief answer. -4.21. In the year 2007, what is the difference between the Bank branche(per 100,000 adults) in Grenada and Bank branche(per 100,000 adults) in Switzerland?
Give a very brief answer. -21.42. In the year 2007, what is the difference between the Bank branche(per 100,000 adults) of Grenada and Bank branche(per 100,000 adults) of West Bank and Gaza?
Your answer should be very brief. 24.54. In the year 2007, what is the difference between the Bank branche(per 100,000 adults) in Switzerland and Bank branche(per 100,000 adults) in West Bank and Gaza?
Give a very brief answer. 45.95. In the year 2008, what is the difference between the Bank branche(per 100,000 adults) of Low & middle income and Bank branche(per 100,000 adults) of Grenada?
Keep it short and to the point. -27.87. In the year 2008, what is the difference between the Bank branche(per 100,000 adults) of Low & middle income and Bank branche(per 100,000 adults) of Switzerland?
Your response must be concise. -48.3. In the year 2008, what is the difference between the Bank branche(per 100,000 adults) of Low & middle income and Bank branche(per 100,000 adults) of West Bank and Gaza?
Keep it short and to the point. -4.76. In the year 2008, what is the difference between the Bank branche(per 100,000 adults) of Grenada and Bank branche(per 100,000 adults) of Switzerland?
Your answer should be compact. -20.42. In the year 2008, what is the difference between the Bank branche(per 100,000 adults) of Grenada and Bank branche(per 100,000 adults) of West Bank and Gaza?
Make the answer very short. 23.12. In the year 2008, what is the difference between the Bank branche(per 100,000 adults) of Switzerland and Bank branche(per 100,000 adults) of West Bank and Gaza?
Ensure brevity in your answer.  43.54. In the year 2009, what is the difference between the Bank branche(per 100,000 adults) in Low & middle income and Bank branche(per 100,000 adults) in Grenada?
Give a very brief answer. -26.92. In the year 2009, what is the difference between the Bank branche(per 100,000 adults) in Low & middle income and Bank branche(per 100,000 adults) in Switzerland?
Offer a very short reply. -46.37. In the year 2009, what is the difference between the Bank branche(per 100,000 adults) of Low & middle income and Bank branche(per 100,000 adults) of West Bank and Gaza?
Ensure brevity in your answer.  -4.52. In the year 2009, what is the difference between the Bank branche(per 100,000 adults) in Grenada and Bank branche(per 100,000 adults) in Switzerland?
Your answer should be compact. -19.45. In the year 2009, what is the difference between the Bank branche(per 100,000 adults) of Grenada and Bank branche(per 100,000 adults) of West Bank and Gaza?
Keep it short and to the point. 22.41. In the year 2009, what is the difference between the Bank branche(per 100,000 adults) of Switzerland and Bank branche(per 100,000 adults) of West Bank and Gaza?
Offer a very short reply. 41.85. In the year 2010, what is the difference between the Bank branche(per 100,000 adults) of Low & middle income and Bank branche(per 100,000 adults) of Grenada?
Provide a succinct answer. -26.83. In the year 2010, what is the difference between the Bank branche(per 100,000 adults) in Low & middle income and Bank branche(per 100,000 adults) in Switzerland?
Provide a succinct answer. -45.65. In the year 2010, what is the difference between the Bank branche(per 100,000 adults) in Low & middle income and Bank branche(per 100,000 adults) in West Bank and Gaza?
Provide a succinct answer. -4.3. In the year 2010, what is the difference between the Bank branche(per 100,000 adults) in Grenada and Bank branche(per 100,000 adults) in Switzerland?
Provide a succinct answer. -18.82. In the year 2010, what is the difference between the Bank branche(per 100,000 adults) in Grenada and Bank branche(per 100,000 adults) in West Bank and Gaza?
Your answer should be very brief. 22.53. In the year 2010, what is the difference between the Bank branche(per 100,000 adults) of Switzerland and Bank branche(per 100,000 adults) of West Bank and Gaza?
Your answer should be very brief. 41.35. In the year 2011, what is the difference between the Bank branche(per 100,000 adults) in Low & middle income and Bank branche(per 100,000 adults) in Grenada?
Your answer should be compact. -27.58. In the year 2011, what is the difference between the Bank branche(per 100,000 adults) of Low & middle income and Bank branche(per 100,000 adults) of Switzerland?
Offer a terse response. -43.8. In the year 2011, what is the difference between the Bank branche(per 100,000 adults) in Low & middle income and Bank branche(per 100,000 adults) in West Bank and Gaza?
Offer a very short reply. -4.18. In the year 2011, what is the difference between the Bank branche(per 100,000 adults) in Grenada and Bank branche(per 100,000 adults) in Switzerland?
Provide a succinct answer. -16.22. In the year 2011, what is the difference between the Bank branche(per 100,000 adults) in Grenada and Bank branche(per 100,000 adults) in West Bank and Gaza?
Provide a short and direct response. 23.4. In the year 2011, what is the difference between the Bank branche(per 100,000 adults) of Switzerland and Bank branche(per 100,000 adults) of West Bank and Gaza?
Give a very brief answer. 39.62. In the year 2012, what is the difference between the Bank branche(per 100,000 adults) of Low & middle income and Bank branche(per 100,000 adults) of Grenada?
Your answer should be very brief. -27.35. In the year 2012, what is the difference between the Bank branche(per 100,000 adults) of Low & middle income and Bank branche(per 100,000 adults) of Switzerland?
Your response must be concise. -41.15. In the year 2012, what is the difference between the Bank branche(per 100,000 adults) in Low & middle income and Bank branche(per 100,000 adults) in West Bank and Gaza?
Keep it short and to the point. -2.68. In the year 2012, what is the difference between the Bank branche(per 100,000 adults) of Grenada and Bank branche(per 100,000 adults) of Switzerland?
Offer a terse response. -13.79. In the year 2012, what is the difference between the Bank branche(per 100,000 adults) of Grenada and Bank branche(per 100,000 adults) of West Bank and Gaza?
Provide a short and direct response. 24.67. In the year 2012, what is the difference between the Bank branche(per 100,000 adults) of Switzerland and Bank branche(per 100,000 adults) of West Bank and Gaza?
Keep it short and to the point. 38.46. What is the ratio of the Bank branche(per 100,000 adults) in Low & middle income in 2005 to that in 2006?
Your answer should be very brief. 0.95. What is the ratio of the Bank branche(per 100,000 adults) in Grenada in 2005 to that in 2006?
Ensure brevity in your answer.  1.01. What is the ratio of the Bank branche(per 100,000 adults) in Switzerland in 2005 to that in 2006?
Your answer should be very brief. 1.02. What is the ratio of the Bank branche(per 100,000 adults) in West Bank and Gaza in 2005 to that in 2006?
Make the answer very short. 0.96. What is the ratio of the Bank branche(per 100,000 adults) in Low & middle income in 2005 to that in 2007?
Your answer should be compact. 0.95. What is the ratio of the Bank branche(per 100,000 adults) in Grenada in 2005 to that in 2007?
Offer a very short reply. 1.03. What is the ratio of the Bank branche(per 100,000 adults) in Switzerland in 2005 to that in 2007?
Keep it short and to the point. 1.03. What is the ratio of the Bank branche(per 100,000 adults) of West Bank and Gaza in 2005 to that in 2007?
Offer a very short reply. 0.94. What is the ratio of the Bank branche(per 100,000 adults) in Low & middle income in 2005 to that in 2008?
Your answer should be very brief. 0.86. What is the ratio of the Bank branche(per 100,000 adults) of Grenada in 2005 to that in 2008?
Offer a terse response. 1.04. What is the ratio of the Bank branche(per 100,000 adults) in Switzerland in 2005 to that in 2008?
Your answer should be compact. 1.05. What is the ratio of the Bank branche(per 100,000 adults) in West Bank and Gaza in 2005 to that in 2008?
Keep it short and to the point. 0.84. What is the ratio of the Bank branche(per 100,000 adults) in Low & middle income in 2005 to that in 2009?
Your answer should be very brief. 0.77. What is the ratio of the Bank branche(per 100,000 adults) of Grenada in 2005 to that in 2009?
Your answer should be very brief. 1.04. What is the ratio of the Bank branche(per 100,000 adults) in Switzerland in 2005 to that in 2009?
Provide a succinct answer. 1.08. What is the ratio of the Bank branche(per 100,000 adults) in West Bank and Gaza in 2005 to that in 2009?
Ensure brevity in your answer.  0.81. What is the ratio of the Bank branche(per 100,000 adults) in Low & middle income in 2005 to that in 2010?
Keep it short and to the point. 0.79. What is the ratio of the Bank branche(per 100,000 adults) in Grenada in 2005 to that in 2010?
Give a very brief answer. 1.05. What is the ratio of the Bank branche(per 100,000 adults) of Switzerland in 2005 to that in 2010?
Offer a terse response. 1.1. What is the ratio of the Bank branche(per 100,000 adults) in West Bank and Gaza in 2005 to that in 2010?
Ensure brevity in your answer.  0.84. What is the ratio of the Bank branche(per 100,000 adults) of Low & middle income in 2005 to that in 2011?
Offer a terse response. 0.75. What is the ratio of the Bank branche(per 100,000 adults) in Switzerland in 2005 to that in 2011?
Your response must be concise. 1.13. What is the ratio of the Bank branche(per 100,000 adults) of West Bank and Gaza in 2005 to that in 2011?
Make the answer very short. 0.82. What is the ratio of the Bank branche(per 100,000 adults) in Low & middle income in 2005 to that in 2012?
Offer a terse response. 0.63. What is the ratio of the Bank branche(per 100,000 adults) in Switzerland in 2005 to that in 2012?
Your answer should be compact. 1.16. What is the ratio of the Bank branche(per 100,000 adults) in West Bank and Gaza in 2005 to that in 2012?
Your answer should be very brief. 0.84. What is the ratio of the Bank branche(per 100,000 adults) of Low & middle income in 2006 to that in 2007?
Your answer should be very brief. 1. What is the ratio of the Bank branche(per 100,000 adults) of Grenada in 2006 to that in 2007?
Your answer should be very brief. 1.01. What is the ratio of the Bank branche(per 100,000 adults) of Switzerland in 2006 to that in 2007?
Your response must be concise. 1.01. What is the ratio of the Bank branche(per 100,000 adults) in West Bank and Gaza in 2006 to that in 2007?
Provide a short and direct response. 0.98. What is the ratio of the Bank branche(per 100,000 adults) of Low & middle income in 2006 to that in 2008?
Offer a very short reply. 0.9. What is the ratio of the Bank branche(per 100,000 adults) in Grenada in 2006 to that in 2008?
Offer a very short reply. 1.02. What is the ratio of the Bank branche(per 100,000 adults) of Switzerland in 2006 to that in 2008?
Your response must be concise. 1.03. What is the ratio of the Bank branche(per 100,000 adults) in West Bank and Gaza in 2006 to that in 2008?
Provide a short and direct response. 0.87. What is the ratio of the Bank branche(per 100,000 adults) of Low & middle income in 2006 to that in 2009?
Give a very brief answer. 0.81. What is the ratio of the Bank branche(per 100,000 adults) of Grenada in 2006 to that in 2009?
Give a very brief answer. 1.03. What is the ratio of the Bank branche(per 100,000 adults) of Switzerland in 2006 to that in 2009?
Ensure brevity in your answer.  1.06. What is the ratio of the Bank branche(per 100,000 adults) of West Bank and Gaza in 2006 to that in 2009?
Your answer should be compact. 0.84. What is the ratio of the Bank branche(per 100,000 adults) of Low & middle income in 2006 to that in 2010?
Provide a short and direct response. 0.83. What is the ratio of the Bank branche(per 100,000 adults) of Grenada in 2006 to that in 2010?
Provide a succinct answer. 1.04. What is the ratio of the Bank branche(per 100,000 adults) in Switzerland in 2006 to that in 2010?
Offer a very short reply. 1.07. What is the ratio of the Bank branche(per 100,000 adults) of West Bank and Gaza in 2006 to that in 2010?
Give a very brief answer. 0.87. What is the ratio of the Bank branche(per 100,000 adults) in Low & middle income in 2006 to that in 2011?
Offer a terse response. 0.79. What is the ratio of the Bank branche(per 100,000 adults) of Grenada in 2006 to that in 2011?
Ensure brevity in your answer.  1.01. What is the ratio of the Bank branche(per 100,000 adults) in Switzerland in 2006 to that in 2011?
Offer a terse response. 1.11. What is the ratio of the Bank branche(per 100,000 adults) of West Bank and Gaza in 2006 to that in 2011?
Offer a very short reply. 0.86. What is the ratio of the Bank branche(per 100,000 adults) in Low & middle income in 2006 to that in 2012?
Provide a short and direct response. 0.66. What is the ratio of the Bank branche(per 100,000 adults) of Grenada in 2006 to that in 2012?
Ensure brevity in your answer.  0.98. What is the ratio of the Bank branche(per 100,000 adults) of Switzerland in 2006 to that in 2012?
Your response must be concise. 1.14. What is the ratio of the Bank branche(per 100,000 adults) in West Bank and Gaza in 2006 to that in 2012?
Make the answer very short. 0.88. What is the ratio of the Bank branche(per 100,000 adults) in Low & middle income in 2007 to that in 2008?
Your answer should be compact. 0.91. What is the ratio of the Bank branche(per 100,000 adults) in Grenada in 2007 to that in 2008?
Offer a terse response. 1.01. What is the ratio of the Bank branche(per 100,000 adults) of Switzerland in 2007 to that in 2008?
Give a very brief answer. 1.02. What is the ratio of the Bank branche(per 100,000 adults) in West Bank and Gaza in 2007 to that in 2008?
Offer a very short reply. 0.9. What is the ratio of the Bank branche(per 100,000 adults) of Low & middle income in 2007 to that in 2009?
Give a very brief answer. 0.81. What is the ratio of the Bank branche(per 100,000 adults) in Switzerland in 2007 to that in 2009?
Offer a very short reply. 1.05. What is the ratio of the Bank branche(per 100,000 adults) of West Bank and Gaza in 2007 to that in 2009?
Offer a terse response. 0.86. What is the ratio of the Bank branche(per 100,000 adults) of Low & middle income in 2007 to that in 2010?
Your answer should be compact. 0.84. What is the ratio of the Bank branche(per 100,000 adults) in Grenada in 2007 to that in 2010?
Your response must be concise. 1.03. What is the ratio of the Bank branche(per 100,000 adults) of Switzerland in 2007 to that in 2010?
Give a very brief answer. 1.07. What is the ratio of the Bank branche(per 100,000 adults) of West Bank and Gaza in 2007 to that in 2010?
Ensure brevity in your answer.  0.89. What is the ratio of the Bank branche(per 100,000 adults) in Low & middle income in 2007 to that in 2011?
Ensure brevity in your answer.  0.8. What is the ratio of the Bank branche(per 100,000 adults) of Grenada in 2007 to that in 2011?
Your answer should be compact. 1. What is the ratio of the Bank branche(per 100,000 adults) in Switzerland in 2007 to that in 2011?
Provide a short and direct response. 1.1. What is the ratio of the Bank branche(per 100,000 adults) of West Bank and Gaza in 2007 to that in 2011?
Your answer should be very brief. 0.88. What is the ratio of the Bank branche(per 100,000 adults) of Low & middle income in 2007 to that in 2012?
Ensure brevity in your answer.  0.66. What is the ratio of the Bank branche(per 100,000 adults) in Switzerland in 2007 to that in 2012?
Provide a succinct answer. 1.13. What is the ratio of the Bank branche(per 100,000 adults) of West Bank and Gaza in 2007 to that in 2012?
Provide a short and direct response. 0.9. What is the ratio of the Bank branche(per 100,000 adults) in Low & middle income in 2008 to that in 2009?
Make the answer very short. 0.9. What is the ratio of the Bank branche(per 100,000 adults) in Switzerland in 2008 to that in 2009?
Your response must be concise. 1.02. What is the ratio of the Bank branche(per 100,000 adults) in West Bank and Gaza in 2008 to that in 2009?
Your response must be concise. 0.96. What is the ratio of the Bank branche(per 100,000 adults) of Low & middle income in 2008 to that in 2010?
Your response must be concise. 0.92. What is the ratio of the Bank branche(per 100,000 adults) in Grenada in 2008 to that in 2010?
Your response must be concise. 1.02. What is the ratio of the Bank branche(per 100,000 adults) in Switzerland in 2008 to that in 2010?
Provide a short and direct response. 1.04. What is the ratio of the Bank branche(per 100,000 adults) in Low & middle income in 2008 to that in 2011?
Give a very brief answer. 0.88. What is the ratio of the Bank branche(per 100,000 adults) in Grenada in 2008 to that in 2011?
Offer a very short reply. 0.99. What is the ratio of the Bank branche(per 100,000 adults) of Switzerland in 2008 to that in 2011?
Offer a terse response. 1.07. What is the ratio of the Bank branche(per 100,000 adults) in Low & middle income in 2008 to that in 2012?
Offer a terse response. 0.73. What is the ratio of the Bank branche(per 100,000 adults) in Grenada in 2008 to that in 2012?
Provide a succinct answer. 0.96. What is the ratio of the Bank branche(per 100,000 adults) in Switzerland in 2008 to that in 2012?
Keep it short and to the point. 1.1. What is the ratio of the Bank branche(per 100,000 adults) in Low & middle income in 2009 to that in 2010?
Give a very brief answer. 1.03. What is the ratio of the Bank branche(per 100,000 adults) in Grenada in 2009 to that in 2010?
Your response must be concise. 1.01. What is the ratio of the Bank branche(per 100,000 adults) in Switzerland in 2009 to that in 2010?
Give a very brief answer. 1.02. What is the ratio of the Bank branche(per 100,000 adults) in West Bank and Gaza in 2009 to that in 2010?
Keep it short and to the point. 1.04. What is the ratio of the Bank branche(per 100,000 adults) in Low & middle income in 2009 to that in 2011?
Keep it short and to the point. 0.98. What is the ratio of the Bank branche(per 100,000 adults) of Grenada in 2009 to that in 2011?
Your answer should be compact. 0.98. What is the ratio of the Bank branche(per 100,000 adults) of Switzerland in 2009 to that in 2011?
Provide a short and direct response. 1.05. What is the ratio of the Bank branche(per 100,000 adults) of West Bank and Gaza in 2009 to that in 2011?
Keep it short and to the point. 1.02. What is the ratio of the Bank branche(per 100,000 adults) in Low & middle income in 2009 to that in 2012?
Keep it short and to the point. 0.82. What is the ratio of the Bank branche(per 100,000 adults) of Grenada in 2009 to that in 2012?
Your answer should be very brief. 0.95. What is the ratio of the Bank branche(per 100,000 adults) in Switzerland in 2009 to that in 2012?
Keep it short and to the point. 1.08. What is the ratio of the Bank branche(per 100,000 adults) of West Bank and Gaza in 2009 to that in 2012?
Make the answer very short. 1.04. What is the ratio of the Bank branche(per 100,000 adults) in Low & middle income in 2010 to that in 2011?
Your answer should be compact. 0.95. What is the ratio of the Bank branche(per 100,000 adults) of Grenada in 2010 to that in 2011?
Your response must be concise. 0.97. What is the ratio of the Bank branche(per 100,000 adults) of Switzerland in 2010 to that in 2011?
Offer a very short reply. 1.03. What is the ratio of the Bank branche(per 100,000 adults) of West Bank and Gaza in 2010 to that in 2011?
Your response must be concise. 0.98. What is the ratio of the Bank branche(per 100,000 adults) of Low & middle income in 2010 to that in 2012?
Provide a short and direct response. 0.79. What is the ratio of the Bank branche(per 100,000 adults) of Grenada in 2010 to that in 2012?
Give a very brief answer. 0.94. What is the ratio of the Bank branche(per 100,000 adults) in Switzerland in 2010 to that in 2012?
Provide a short and direct response. 1.06. What is the ratio of the Bank branche(per 100,000 adults) of West Bank and Gaza in 2010 to that in 2012?
Make the answer very short. 1. What is the ratio of the Bank branche(per 100,000 adults) in Low & middle income in 2011 to that in 2012?
Provide a short and direct response. 0.83. What is the ratio of the Bank branche(per 100,000 adults) of Switzerland in 2011 to that in 2012?
Provide a short and direct response. 1.03. What is the ratio of the Bank branche(per 100,000 adults) of West Bank and Gaza in 2011 to that in 2012?
Offer a very short reply. 1.02. What is the difference between the highest and the second highest Bank branche(per 100,000 adults) of Low & middle income?
Keep it short and to the point. 1.28. What is the difference between the highest and the second highest Bank branche(per 100,000 adults) of Grenada?
Make the answer very short. 0.34. What is the difference between the highest and the second highest Bank branche(per 100,000 adults) of Switzerland?
Give a very brief answer. 1.18. What is the difference between the highest and the second highest Bank branche(per 100,000 adults) in West Bank and Gaza?
Your answer should be compact. 0.22. What is the difference between the highest and the lowest Bank branche(per 100,000 adults) of Low & middle income?
Give a very brief answer. 2.86. What is the difference between the highest and the lowest Bank branche(per 100,000 adults) of Grenada?
Provide a succinct answer. 2.1. What is the difference between the highest and the lowest Bank branche(per 100,000 adults) of Switzerland?
Ensure brevity in your answer.  7.95. What is the difference between the highest and the lowest Bank branche(per 100,000 adults) in West Bank and Gaza?
Ensure brevity in your answer.  2.09. 